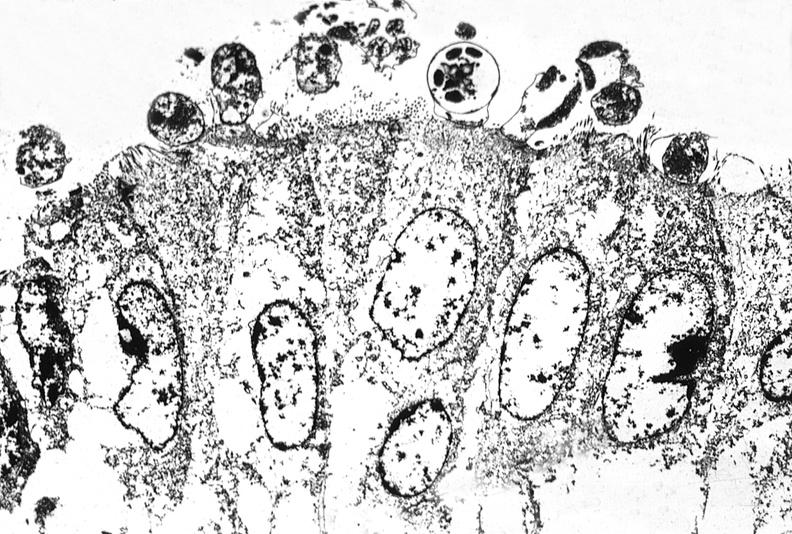s krukenberg tumor present?
Answer the question using a single word or phrase. No 